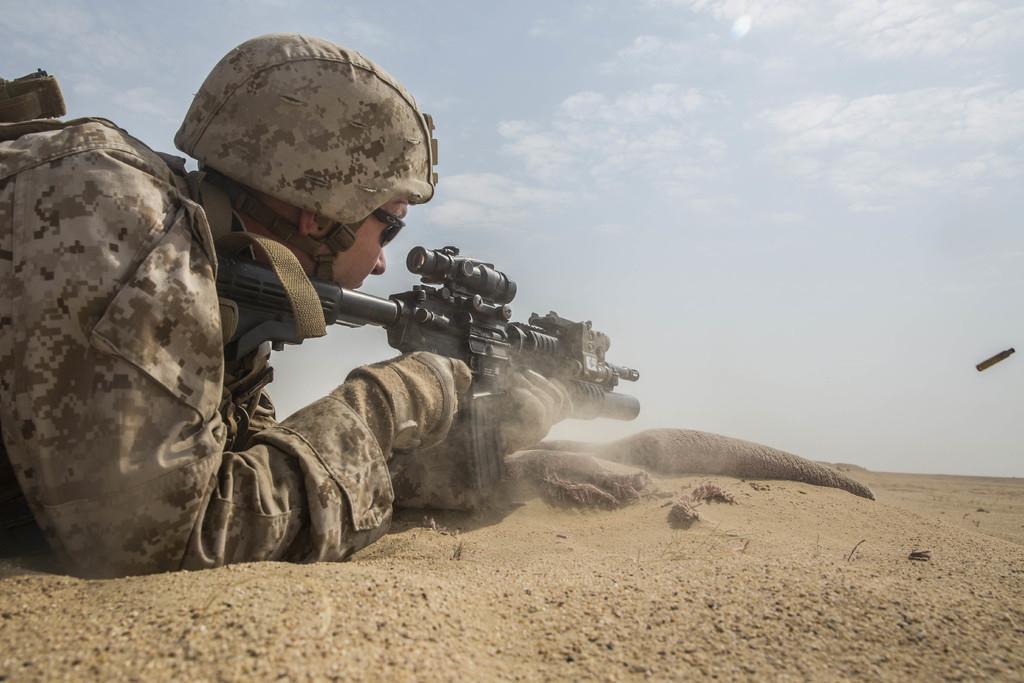Could you give a brief overview of what you see in this image? In this image we can see a person lying on the ground and holding a gun, there is a bullet and the sky with clouds in the background. 